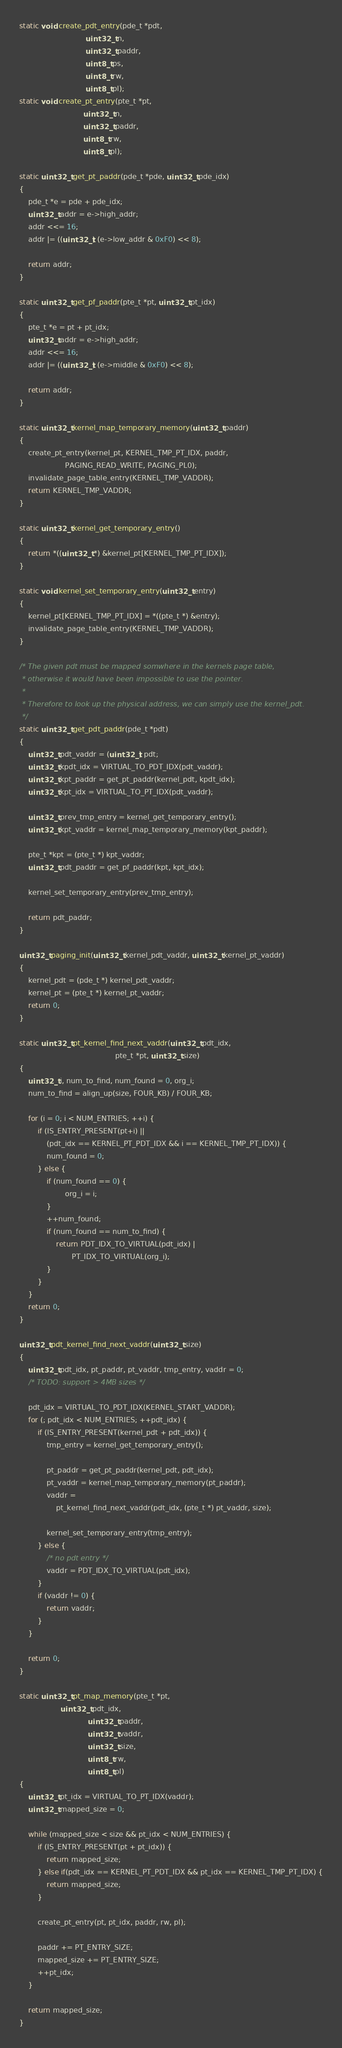<code> <loc_0><loc_0><loc_500><loc_500><_C_>static void create_pdt_entry(pde_t *pdt,
                             uint32_t n,
                             uint32_t paddr,
                             uint8_t ps,
                             uint8_t rw,
                             uint8_t pl);
static void create_pt_entry(pte_t *pt,
                            uint32_t n,
                            uint32_t paddr,
                            uint8_t rw,
                            uint8_t pl);

static uint32_t get_pt_paddr(pde_t *pde, uint32_t pde_idx)
{
    pde_t *e = pde + pde_idx;
    uint32_t addr = e->high_addr;
    addr <<= 16;
    addr |= ((uint32_t) (e->low_addr & 0xF0) << 8);

    return addr;
}

static uint32_t get_pf_paddr(pte_t *pt, uint32_t pt_idx)
{
    pte_t *e = pt + pt_idx;
    uint32_t addr = e->high_addr;
    addr <<= 16;
    addr |= ((uint32_t) (e->middle & 0xF0) << 8);

    return addr;
}

static uint32_t kernel_map_temporary_memory(uint32_t paddr)
{
    create_pt_entry(kernel_pt, KERNEL_TMP_PT_IDX, paddr,
                    PAGING_READ_WRITE, PAGING_PL0);
    invalidate_page_table_entry(KERNEL_TMP_VADDR);
    return KERNEL_TMP_VADDR;
}

static uint32_t kernel_get_temporary_entry()
{
    return *((uint32_t *) &kernel_pt[KERNEL_TMP_PT_IDX]);
}

static void kernel_set_temporary_entry(uint32_t entry)
{
    kernel_pt[KERNEL_TMP_PT_IDX] = *((pte_t *) &entry);
    invalidate_page_table_entry(KERNEL_TMP_VADDR);
}

/* The given pdt must be mapped somwhere in the kernels page table,
 * otherwise it would have been impossible to use the pointer.
 *
 * Therefore to look up the physical address, we can simply use the kernel_pdt.
 */
static uint32_t get_pdt_paddr(pde_t *pdt)
{
    uint32_t pdt_vaddr = (uint32_t) pdt;
    uint32_t kpdt_idx = VIRTUAL_TO_PDT_IDX(pdt_vaddr);
    uint32_t kpt_paddr = get_pt_paddr(kernel_pdt, kpdt_idx);
    uint32_t kpt_idx = VIRTUAL_TO_PT_IDX(pdt_vaddr);

    uint32_t prev_tmp_entry = kernel_get_temporary_entry();
    uint32_t kpt_vaddr = kernel_map_temporary_memory(kpt_paddr);

    pte_t *kpt = (pte_t *) kpt_vaddr;
    uint32_t pdt_paddr = get_pf_paddr(kpt, kpt_idx);

    kernel_set_temporary_entry(prev_tmp_entry);

    return pdt_paddr;
}

uint32_t paging_init(uint32_t kernel_pdt_vaddr, uint32_t kernel_pt_vaddr)
{
    kernel_pdt = (pde_t *) kernel_pdt_vaddr;
    kernel_pt = (pte_t *) kernel_pt_vaddr;
    return 0;
}

static uint32_t pt_kernel_find_next_vaddr(uint32_t pdt_idx,
                                          pte_t *pt, uint32_t size)
{
    uint32_t i, num_to_find, num_found = 0, org_i;
    num_to_find = align_up(size, FOUR_KB) / FOUR_KB;

    for (i = 0; i < NUM_ENTRIES; ++i) {
        if (IS_ENTRY_PRESENT(pt+i) ||
            (pdt_idx == KERNEL_PT_PDT_IDX && i == KERNEL_TMP_PT_IDX)) {
            num_found = 0;
        } else {
            if (num_found == 0) {
                    org_i = i;
            }
            ++num_found;
            if (num_found == num_to_find) {
                return PDT_IDX_TO_VIRTUAL(pdt_idx) |
                       PT_IDX_TO_VIRTUAL(org_i);
            }
        }
    }
    return 0;
}

uint32_t pdt_kernel_find_next_vaddr(uint32_t size)
{
    uint32_t pdt_idx, pt_paddr, pt_vaddr, tmp_entry, vaddr = 0;
    /* TODO: support > 4MB sizes */

    pdt_idx = VIRTUAL_TO_PDT_IDX(KERNEL_START_VADDR);
    for (; pdt_idx < NUM_ENTRIES; ++pdt_idx) {
        if (IS_ENTRY_PRESENT(kernel_pdt + pdt_idx)) {
			tmp_entry = kernel_get_temporary_entry();

            pt_paddr = get_pt_paddr(kernel_pdt, pdt_idx);
            pt_vaddr = kernel_map_temporary_memory(pt_paddr);
            vaddr =
                pt_kernel_find_next_vaddr(pdt_idx, (pte_t *) pt_vaddr, size);

	        kernel_set_temporary_entry(tmp_entry);
        } else {
            /* no pdt entry */
            vaddr = PDT_IDX_TO_VIRTUAL(pdt_idx);
        }
        if (vaddr != 0) {
            return vaddr;
        }
    }

    return 0;
}

static uint32_t pt_map_memory(pte_t *pt,
			      uint32_t pdt_idx,
                              uint32_t paddr,
                              uint32_t vaddr,
                              uint32_t size,
                              uint8_t rw,
                              uint8_t pl)
{
    uint32_t pt_idx = VIRTUAL_TO_PT_IDX(vaddr);
    uint32_t mapped_size = 0;

    while (mapped_size < size && pt_idx < NUM_ENTRIES) {
        if (IS_ENTRY_PRESENT(pt + pt_idx)) {
            return mapped_size;
        } else if(pdt_idx == KERNEL_PT_PDT_IDX && pt_idx == KERNEL_TMP_PT_IDX) {
            return mapped_size;
        }

        create_pt_entry(pt, pt_idx, paddr, rw, pl);

        paddr += PT_ENTRY_SIZE;
        mapped_size += PT_ENTRY_SIZE;
        ++pt_idx;
    }

    return mapped_size;
}
</code> 